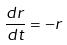Convert formula to latex. <formula><loc_0><loc_0><loc_500><loc_500>\frac { d r } { d t } = - r</formula> 